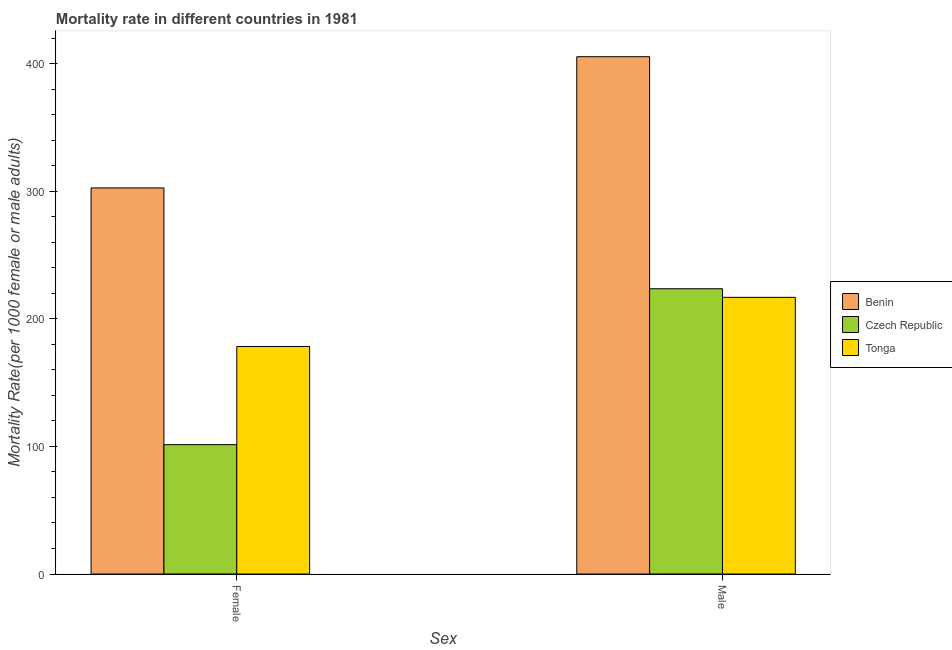Are the number of bars on each tick of the X-axis equal?
Your answer should be compact. Yes. What is the male mortality rate in Benin?
Make the answer very short. 405.53. Across all countries, what is the maximum female mortality rate?
Offer a very short reply. 302.67. Across all countries, what is the minimum male mortality rate?
Make the answer very short. 216.88. In which country was the female mortality rate maximum?
Your response must be concise. Benin. In which country was the male mortality rate minimum?
Keep it short and to the point. Tonga. What is the total female mortality rate in the graph?
Offer a terse response. 582.42. What is the difference between the male mortality rate in Benin and that in Czech Republic?
Ensure brevity in your answer.  181.91. What is the difference between the male mortality rate in Czech Republic and the female mortality rate in Tonga?
Provide a succinct answer. 45.26. What is the average female mortality rate per country?
Offer a very short reply. 194.14. What is the difference between the male mortality rate and female mortality rate in Benin?
Offer a terse response. 102.87. What is the ratio of the male mortality rate in Benin to that in Tonga?
Provide a succinct answer. 1.87. What does the 2nd bar from the left in Male represents?
Your response must be concise. Czech Republic. What does the 1st bar from the right in Male represents?
Your response must be concise. Tonga. Are all the bars in the graph horizontal?
Keep it short and to the point. No. How many countries are there in the graph?
Provide a short and direct response. 3. What is the difference between two consecutive major ticks on the Y-axis?
Offer a very short reply. 100. Are the values on the major ticks of Y-axis written in scientific E-notation?
Offer a very short reply. No. Does the graph contain grids?
Your answer should be compact. No. How are the legend labels stacked?
Your response must be concise. Vertical. What is the title of the graph?
Your answer should be very brief. Mortality rate in different countries in 1981. Does "Canada" appear as one of the legend labels in the graph?
Ensure brevity in your answer.  No. What is the label or title of the X-axis?
Provide a succinct answer. Sex. What is the label or title of the Y-axis?
Give a very brief answer. Mortality Rate(per 1000 female or male adults). What is the Mortality Rate(per 1000 female or male adults) of Benin in Female?
Provide a short and direct response. 302.67. What is the Mortality Rate(per 1000 female or male adults) of Czech Republic in Female?
Keep it short and to the point. 101.39. What is the Mortality Rate(per 1000 female or male adults) in Tonga in Female?
Offer a terse response. 178.36. What is the Mortality Rate(per 1000 female or male adults) in Benin in Male?
Your response must be concise. 405.53. What is the Mortality Rate(per 1000 female or male adults) in Czech Republic in Male?
Your response must be concise. 223.62. What is the Mortality Rate(per 1000 female or male adults) of Tonga in Male?
Give a very brief answer. 216.88. Across all Sex, what is the maximum Mortality Rate(per 1000 female or male adults) in Benin?
Provide a succinct answer. 405.53. Across all Sex, what is the maximum Mortality Rate(per 1000 female or male adults) in Czech Republic?
Provide a short and direct response. 223.62. Across all Sex, what is the maximum Mortality Rate(per 1000 female or male adults) of Tonga?
Your answer should be very brief. 216.88. Across all Sex, what is the minimum Mortality Rate(per 1000 female or male adults) of Benin?
Offer a terse response. 302.67. Across all Sex, what is the minimum Mortality Rate(per 1000 female or male adults) of Czech Republic?
Keep it short and to the point. 101.39. Across all Sex, what is the minimum Mortality Rate(per 1000 female or male adults) in Tonga?
Ensure brevity in your answer.  178.36. What is the total Mortality Rate(per 1000 female or male adults) of Benin in the graph?
Keep it short and to the point. 708.2. What is the total Mortality Rate(per 1000 female or male adults) of Czech Republic in the graph?
Provide a short and direct response. 325.01. What is the total Mortality Rate(per 1000 female or male adults) in Tonga in the graph?
Make the answer very short. 395.25. What is the difference between the Mortality Rate(per 1000 female or male adults) in Benin in Female and that in Male?
Give a very brief answer. -102.86. What is the difference between the Mortality Rate(per 1000 female or male adults) of Czech Republic in Female and that in Male?
Your response must be concise. -122.23. What is the difference between the Mortality Rate(per 1000 female or male adults) in Tonga in Female and that in Male?
Give a very brief answer. -38.52. What is the difference between the Mortality Rate(per 1000 female or male adults) of Benin in Female and the Mortality Rate(per 1000 female or male adults) of Czech Republic in Male?
Make the answer very short. 79.04. What is the difference between the Mortality Rate(per 1000 female or male adults) in Benin in Female and the Mortality Rate(per 1000 female or male adults) in Tonga in Male?
Your answer should be compact. 85.78. What is the difference between the Mortality Rate(per 1000 female or male adults) in Czech Republic in Female and the Mortality Rate(per 1000 female or male adults) in Tonga in Male?
Your answer should be compact. -115.5. What is the average Mortality Rate(per 1000 female or male adults) of Benin per Sex?
Offer a very short reply. 354.1. What is the average Mortality Rate(per 1000 female or male adults) in Czech Republic per Sex?
Ensure brevity in your answer.  162.51. What is the average Mortality Rate(per 1000 female or male adults) of Tonga per Sex?
Keep it short and to the point. 197.62. What is the difference between the Mortality Rate(per 1000 female or male adults) in Benin and Mortality Rate(per 1000 female or male adults) in Czech Republic in Female?
Your answer should be compact. 201.28. What is the difference between the Mortality Rate(per 1000 female or male adults) of Benin and Mortality Rate(per 1000 female or male adults) of Tonga in Female?
Give a very brief answer. 124.31. What is the difference between the Mortality Rate(per 1000 female or male adults) of Czech Republic and Mortality Rate(per 1000 female or male adults) of Tonga in Female?
Give a very brief answer. -76.97. What is the difference between the Mortality Rate(per 1000 female or male adults) in Benin and Mortality Rate(per 1000 female or male adults) in Czech Republic in Male?
Ensure brevity in your answer.  181.91. What is the difference between the Mortality Rate(per 1000 female or male adults) of Benin and Mortality Rate(per 1000 female or male adults) of Tonga in Male?
Offer a terse response. 188.65. What is the difference between the Mortality Rate(per 1000 female or male adults) in Czech Republic and Mortality Rate(per 1000 female or male adults) in Tonga in Male?
Offer a very short reply. 6.74. What is the ratio of the Mortality Rate(per 1000 female or male adults) in Benin in Female to that in Male?
Your answer should be very brief. 0.75. What is the ratio of the Mortality Rate(per 1000 female or male adults) in Czech Republic in Female to that in Male?
Provide a succinct answer. 0.45. What is the ratio of the Mortality Rate(per 1000 female or male adults) of Tonga in Female to that in Male?
Keep it short and to the point. 0.82. What is the difference between the highest and the second highest Mortality Rate(per 1000 female or male adults) of Benin?
Ensure brevity in your answer.  102.86. What is the difference between the highest and the second highest Mortality Rate(per 1000 female or male adults) of Czech Republic?
Ensure brevity in your answer.  122.23. What is the difference between the highest and the second highest Mortality Rate(per 1000 female or male adults) of Tonga?
Your answer should be very brief. 38.52. What is the difference between the highest and the lowest Mortality Rate(per 1000 female or male adults) of Benin?
Offer a very short reply. 102.86. What is the difference between the highest and the lowest Mortality Rate(per 1000 female or male adults) in Czech Republic?
Your response must be concise. 122.23. What is the difference between the highest and the lowest Mortality Rate(per 1000 female or male adults) of Tonga?
Offer a terse response. 38.52. 